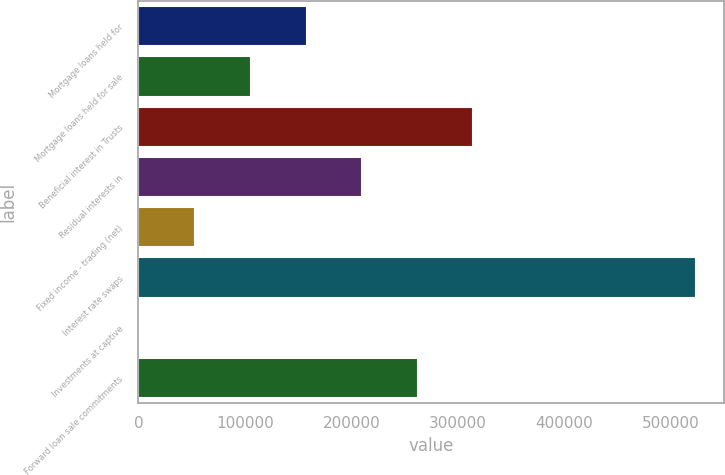Convert chart to OTSL. <chart><loc_0><loc_0><loc_500><loc_500><bar_chart><fcel>Mortgage loans held for<fcel>Mortgage loans held for sale<fcel>Beneficial interest in Trusts<fcel>Residual interests in<fcel>Fixed income - trading (net)<fcel>Interest rate swaps<fcel>Investments at captive<fcel>Forward loan sale commitments<nl><fcel>157974<fcel>105736<fcel>314687<fcel>210212<fcel>53497.9<fcel>523639<fcel>1260<fcel>262450<nl></chart> 